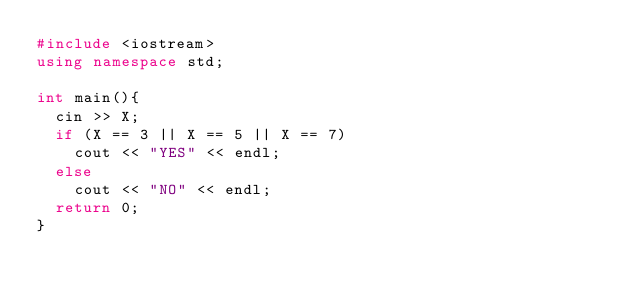<code> <loc_0><loc_0><loc_500><loc_500><_C++_>#include <iostream>
using namespace std;

int main(){
  cin >> X;
  if (X == 3 || X == 5 || X == 7)
    cout << "YES" << endl;
  else
    cout << "NO" << endl;
  return 0;
}</code> 